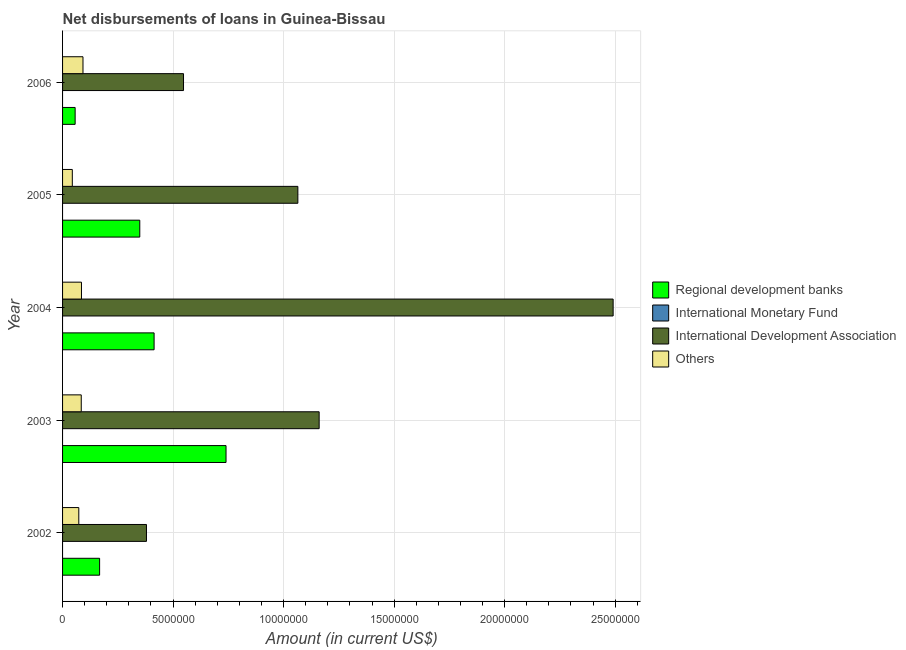How many different coloured bars are there?
Ensure brevity in your answer.  3. How many groups of bars are there?
Keep it short and to the point. 5. Are the number of bars per tick equal to the number of legend labels?
Your response must be concise. No. Are the number of bars on each tick of the Y-axis equal?
Your answer should be compact. Yes. How many bars are there on the 4th tick from the top?
Offer a very short reply. 3. How many bars are there on the 2nd tick from the bottom?
Provide a succinct answer. 3. What is the label of the 1st group of bars from the top?
Ensure brevity in your answer.  2006. What is the amount of loan disimbursed by other organisations in 2006?
Your answer should be compact. 9.24e+05. Across all years, what is the maximum amount of loan disimbursed by other organisations?
Your response must be concise. 9.24e+05. What is the total amount of loan disimbursed by international monetary fund in the graph?
Make the answer very short. 0. What is the difference between the amount of loan disimbursed by international development association in 2004 and that in 2006?
Your response must be concise. 1.94e+07. What is the difference between the amount of loan disimbursed by regional development banks in 2003 and the amount of loan disimbursed by international monetary fund in 2006?
Your response must be concise. 7.40e+06. What is the average amount of loan disimbursed by other organisations per year?
Your answer should be very brief. 7.60e+05. In the year 2004, what is the difference between the amount of loan disimbursed by international development association and amount of loan disimbursed by regional development banks?
Make the answer very short. 2.08e+07. In how many years, is the amount of loan disimbursed by regional development banks greater than 12000000 US$?
Offer a very short reply. 0. What is the ratio of the amount of loan disimbursed by regional development banks in 2003 to that in 2004?
Your response must be concise. 1.79. Is the amount of loan disimbursed by international development association in 2002 less than that in 2005?
Give a very brief answer. Yes. What is the difference between the highest and the second highest amount of loan disimbursed by regional development banks?
Offer a terse response. 3.25e+06. What is the difference between the highest and the lowest amount of loan disimbursed by other organisations?
Your response must be concise. 4.83e+05. Is the sum of the amount of loan disimbursed by regional development banks in 2002 and 2005 greater than the maximum amount of loan disimbursed by other organisations across all years?
Give a very brief answer. Yes. Is it the case that in every year, the sum of the amount of loan disimbursed by international monetary fund and amount of loan disimbursed by international development association is greater than the sum of amount of loan disimbursed by regional development banks and amount of loan disimbursed by other organisations?
Your answer should be very brief. Yes. Are all the bars in the graph horizontal?
Make the answer very short. Yes. How many years are there in the graph?
Your answer should be compact. 5. Does the graph contain grids?
Provide a succinct answer. Yes. How many legend labels are there?
Your response must be concise. 4. What is the title of the graph?
Give a very brief answer. Net disbursements of loans in Guinea-Bissau. What is the label or title of the X-axis?
Offer a terse response. Amount (in current US$). What is the Amount (in current US$) in Regional development banks in 2002?
Keep it short and to the point. 1.68e+06. What is the Amount (in current US$) of International Monetary Fund in 2002?
Offer a very short reply. 0. What is the Amount (in current US$) of International Development Association in 2002?
Give a very brief answer. 3.80e+06. What is the Amount (in current US$) in Others in 2002?
Your response must be concise. 7.34e+05. What is the Amount (in current US$) of Regional development banks in 2003?
Offer a very short reply. 7.40e+06. What is the Amount (in current US$) of International Monetary Fund in 2003?
Your response must be concise. 0. What is the Amount (in current US$) in International Development Association in 2003?
Your answer should be compact. 1.16e+07. What is the Amount (in current US$) of Others in 2003?
Ensure brevity in your answer.  8.45e+05. What is the Amount (in current US$) in Regional development banks in 2004?
Offer a very short reply. 4.14e+06. What is the Amount (in current US$) in International Development Association in 2004?
Keep it short and to the point. 2.49e+07. What is the Amount (in current US$) of Others in 2004?
Ensure brevity in your answer.  8.55e+05. What is the Amount (in current US$) of Regional development banks in 2005?
Your response must be concise. 3.49e+06. What is the Amount (in current US$) of International Monetary Fund in 2005?
Provide a short and direct response. 0. What is the Amount (in current US$) in International Development Association in 2005?
Ensure brevity in your answer.  1.06e+07. What is the Amount (in current US$) of Others in 2005?
Make the answer very short. 4.41e+05. What is the Amount (in current US$) of Regional development banks in 2006?
Keep it short and to the point. 5.69e+05. What is the Amount (in current US$) in International Monetary Fund in 2006?
Make the answer very short. 0. What is the Amount (in current US$) in International Development Association in 2006?
Your answer should be compact. 5.47e+06. What is the Amount (in current US$) in Others in 2006?
Give a very brief answer. 9.24e+05. Across all years, what is the maximum Amount (in current US$) of Regional development banks?
Offer a very short reply. 7.40e+06. Across all years, what is the maximum Amount (in current US$) of International Development Association?
Keep it short and to the point. 2.49e+07. Across all years, what is the maximum Amount (in current US$) in Others?
Your answer should be compact. 9.24e+05. Across all years, what is the minimum Amount (in current US$) in Regional development banks?
Provide a short and direct response. 5.69e+05. Across all years, what is the minimum Amount (in current US$) of International Development Association?
Provide a succinct answer. 3.80e+06. Across all years, what is the minimum Amount (in current US$) in Others?
Make the answer very short. 4.41e+05. What is the total Amount (in current US$) in Regional development banks in the graph?
Offer a very short reply. 1.73e+07. What is the total Amount (in current US$) in International Monetary Fund in the graph?
Your response must be concise. 0. What is the total Amount (in current US$) in International Development Association in the graph?
Provide a short and direct response. 5.64e+07. What is the total Amount (in current US$) of Others in the graph?
Provide a short and direct response. 3.80e+06. What is the difference between the Amount (in current US$) in Regional development banks in 2002 and that in 2003?
Make the answer very short. -5.72e+06. What is the difference between the Amount (in current US$) in International Development Association in 2002 and that in 2003?
Your answer should be very brief. -7.81e+06. What is the difference between the Amount (in current US$) of Others in 2002 and that in 2003?
Make the answer very short. -1.11e+05. What is the difference between the Amount (in current US$) in Regional development banks in 2002 and that in 2004?
Your answer should be compact. -2.46e+06. What is the difference between the Amount (in current US$) of International Development Association in 2002 and that in 2004?
Ensure brevity in your answer.  -2.11e+07. What is the difference between the Amount (in current US$) in Others in 2002 and that in 2004?
Your answer should be compact. -1.21e+05. What is the difference between the Amount (in current US$) of Regional development banks in 2002 and that in 2005?
Ensure brevity in your answer.  -1.82e+06. What is the difference between the Amount (in current US$) in International Development Association in 2002 and that in 2005?
Give a very brief answer. -6.85e+06. What is the difference between the Amount (in current US$) of Others in 2002 and that in 2005?
Keep it short and to the point. 2.93e+05. What is the difference between the Amount (in current US$) in Regional development banks in 2002 and that in 2006?
Keep it short and to the point. 1.11e+06. What is the difference between the Amount (in current US$) of International Development Association in 2002 and that in 2006?
Provide a succinct answer. -1.68e+06. What is the difference between the Amount (in current US$) of Others in 2002 and that in 2006?
Give a very brief answer. -1.90e+05. What is the difference between the Amount (in current US$) in Regional development banks in 2003 and that in 2004?
Keep it short and to the point. 3.25e+06. What is the difference between the Amount (in current US$) in International Development Association in 2003 and that in 2004?
Your answer should be compact. -1.33e+07. What is the difference between the Amount (in current US$) of Regional development banks in 2003 and that in 2005?
Make the answer very short. 3.90e+06. What is the difference between the Amount (in current US$) of International Development Association in 2003 and that in 2005?
Make the answer very short. 9.63e+05. What is the difference between the Amount (in current US$) in Others in 2003 and that in 2005?
Ensure brevity in your answer.  4.04e+05. What is the difference between the Amount (in current US$) of Regional development banks in 2003 and that in 2006?
Ensure brevity in your answer.  6.83e+06. What is the difference between the Amount (in current US$) of International Development Association in 2003 and that in 2006?
Give a very brief answer. 6.14e+06. What is the difference between the Amount (in current US$) in Others in 2003 and that in 2006?
Give a very brief answer. -7.90e+04. What is the difference between the Amount (in current US$) of Regional development banks in 2004 and that in 2005?
Offer a very short reply. 6.48e+05. What is the difference between the Amount (in current US$) in International Development Association in 2004 and that in 2005?
Make the answer very short. 1.43e+07. What is the difference between the Amount (in current US$) in Others in 2004 and that in 2005?
Keep it short and to the point. 4.14e+05. What is the difference between the Amount (in current US$) in Regional development banks in 2004 and that in 2006?
Offer a very short reply. 3.57e+06. What is the difference between the Amount (in current US$) in International Development Association in 2004 and that in 2006?
Make the answer very short. 1.94e+07. What is the difference between the Amount (in current US$) of Others in 2004 and that in 2006?
Keep it short and to the point. -6.90e+04. What is the difference between the Amount (in current US$) of Regional development banks in 2005 and that in 2006?
Your answer should be very brief. 2.92e+06. What is the difference between the Amount (in current US$) of International Development Association in 2005 and that in 2006?
Your response must be concise. 5.17e+06. What is the difference between the Amount (in current US$) of Others in 2005 and that in 2006?
Your answer should be very brief. -4.83e+05. What is the difference between the Amount (in current US$) of Regional development banks in 2002 and the Amount (in current US$) of International Development Association in 2003?
Offer a terse response. -9.93e+06. What is the difference between the Amount (in current US$) of Regional development banks in 2002 and the Amount (in current US$) of Others in 2003?
Your answer should be very brief. 8.31e+05. What is the difference between the Amount (in current US$) of International Development Association in 2002 and the Amount (in current US$) of Others in 2003?
Ensure brevity in your answer.  2.95e+06. What is the difference between the Amount (in current US$) of Regional development banks in 2002 and the Amount (in current US$) of International Development Association in 2004?
Make the answer very short. -2.32e+07. What is the difference between the Amount (in current US$) in Regional development banks in 2002 and the Amount (in current US$) in Others in 2004?
Offer a very short reply. 8.21e+05. What is the difference between the Amount (in current US$) of International Development Association in 2002 and the Amount (in current US$) of Others in 2004?
Give a very brief answer. 2.94e+06. What is the difference between the Amount (in current US$) in Regional development banks in 2002 and the Amount (in current US$) in International Development Association in 2005?
Ensure brevity in your answer.  -8.97e+06. What is the difference between the Amount (in current US$) of Regional development banks in 2002 and the Amount (in current US$) of Others in 2005?
Offer a very short reply. 1.24e+06. What is the difference between the Amount (in current US$) in International Development Association in 2002 and the Amount (in current US$) in Others in 2005?
Your response must be concise. 3.36e+06. What is the difference between the Amount (in current US$) in Regional development banks in 2002 and the Amount (in current US$) in International Development Association in 2006?
Provide a short and direct response. -3.80e+06. What is the difference between the Amount (in current US$) of Regional development banks in 2002 and the Amount (in current US$) of Others in 2006?
Give a very brief answer. 7.52e+05. What is the difference between the Amount (in current US$) of International Development Association in 2002 and the Amount (in current US$) of Others in 2006?
Provide a succinct answer. 2.87e+06. What is the difference between the Amount (in current US$) of Regional development banks in 2003 and the Amount (in current US$) of International Development Association in 2004?
Offer a very short reply. -1.75e+07. What is the difference between the Amount (in current US$) of Regional development banks in 2003 and the Amount (in current US$) of Others in 2004?
Provide a succinct answer. 6.54e+06. What is the difference between the Amount (in current US$) in International Development Association in 2003 and the Amount (in current US$) in Others in 2004?
Make the answer very short. 1.08e+07. What is the difference between the Amount (in current US$) in Regional development banks in 2003 and the Amount (in current US$) in International Development Association in 2005?
Give a very brief answer. -3.25e+06. What is the difference between the Amount (in current US$) of Regional development banks in 2003 and the Amount (in current US$) of Others in 2005?
Provide a short and direct response. 6.95e+06. What is the difference between the Amount (in current US$) of International Development Association in 2003 and the Amount (in current US$) of Others in 2005?
Make the answer very short. 1.12e+07. What is the difference between the Amount (in current US$) in Regional development banks in 2003 and the Amount (in current US$) in International Development Association in 2006?
Your response must be concise. 1.92e+06. What is the difference between the Amount (in current US$) of Regional development banks in 2003 and the Amount (in current US$) of Others in 2006?
Your response must be concise. 6.47e+06. What is the difference between the Amount (in current US$) of International Development Association in 2003 and the Amount (in current US$) of Others in 2006?
Provide a succinct answer. 1.07e+07. What is the difference between the Amount (in current US$) in Regional development banks in 2004 and the Amount (in current US$) in International Development Association in 2005?
Provide a short and direct response. -6.50e+06. What is the difference between the Amount (in current US$) of Regional development banks in 2004 and the Amount (in current US$) of Others in 2005?
Your answer should be very brief. 3.70e+06. What is the difference between the Amount (in current US$) in International Development Association in 2004 and the Amount (in current US$) in Others in 2005?
Your answer should be compact. 2.45e+07. What is the difference between the Amount (in current US$) in Regional development banks in 2004 and the Amount (in current US$) in International Development Association in 2006?
Make the answer very short. -1.33e+06. What is the difference between the Amount (in current US$) of Regional development banks in 2004 and the Amount (in current US$) of Others in 2006?
Offer a very short reply. 3.22e+06. What is the difference between the Amount (in current US$) of International Development Association in 2004 and the Amount (in current US$) of Others in 2006?
Your answer should be very brief. 2.40e+07. What is the difference between the Amount (in current US$) of Regional development banks in 2005 and the Amount (in current US$) of International Development Association in 2006?
Provide a succinct answer. -1.98e+06. What is the difference between the Amount (in current US$) of Regional development banks in 2005 and the Amount (in current US$) of Others in 2006?
Give a very brief answer. 2.57e+06. What is the difference between the Amount (in current US$) in International Development Association in 2005 and the Amount (in current US$) in Others in 2006?
Your answer should be compact. 9.72e+06. What is the average Amount (in current US$) in Regional development banks per year?
Keep it short and to the point. 3.45e+06. What is the average Amount (in current US$) in International Monetary Fund per year?
Make the answer very short. 0. What is the average Amount (in current US$) of International Development Association per year?
Provide a succinct answer. 1.13e+07. What is the average Amount (in current US$) of Others per year?
Ensure brevity in your answer.  7.60e+05. In the year 2002, what is the difference between the Amount (in current US$) in Regional development banks and Amount (in current US$) in International Development Association?
Give a very brief answer. -2.12e+06. In the year 2002, what is the difference between the Amount (in current US$) in Regional development banks and Amount (in current US$) in Others?
Offer a terse response. 9.42e+05. In the year 2002, what is the difference between the Amount (in current US$) of International Development Association and Amount (in current US$) of Others?
Give a very brief answer. 3.06e+06. In the year 2003, what is the difference between the Amount (in current US$) of Regional development banks and Amount (in current US$) of International Development Association?
Keep it short and to the point. -4.21e+06. In the year 2003, what is the difference between the Amount (in current US$) of Regional development banks and Amount (in current US$) of Others?
Your response must be concise. 6.55e+06. In the year 2003, what is the difference between the Amount (in current US$) in International Development Association and Amount (in current US$) in Others?
Your answer should be compact. 1.08e+07. In the year 2004, what is the difference between the Amount (in current US$) of Regional development banks and Amount (in current US$) of International Development Association?
Make the answer very short. -2.08e+07. In the year 2004, what is the difference between the Amount (in current US$) in Regional development banks and Amount (in current US$) in Others?
Provide a succinct answer. 3.29e+06. In the year 2004, what is the difference between the Amount (in current US$) in International Development Association and Amount (in current US$) in Others?
Offer a terse response. 2.41e+07. In the year 2005, what is the difference between the Amount (in current US$) in Regional development banks and Amount (in current US$) in International Development Association?
Your answer should be very brief. -7.15e+06. In the year 2005, what is the difference between the Amount (in current US$) in Regional development banks and Amount (in current US$) in Others?
Make the answer very short. 3.05e+06. In the year 2005, what is the difference between the Amount (in current US$) of International Development Association and Amount (in current US$) of Others?
Ensure brevity in your answer.  1.02e+07. In the year 2006, what is the difference between the Amount (in current US$) in Regional development banks and Amount (in current US$) in International Development Association?
Provide a short and direct response. -4.90e+06. In the year 2006, what is the difference between the Amount (in current US$) in Regional development banks and Amount (in current US$) in Others?
Give a very brief answer. -3.55e+05. In the year 2006, what is the difference between the Amount (in current US$) in International Development Association and Amount (in current US$) in Others?
Provide a short and direct response. 4.55e+06. What is the ratio of the Amount (in current US$) of Regional development banks in 2002 to that in 2003?
Your response must be concise. 0.23. What is the ratio of the Amount (in current US$) of International Development Association in 2002 to that in 2003?
Give a very brief answer. 0.33. What is the ratio of the Amount (in current US$) of Others in 2002 to that in 2003?
Offer a terse response. 0.87. What is the ratio of the Amount (in current US$) of Regional development banks in 2002 to that in 2004?
Your answer should be compact. 0.4. What is the ratio of the Amount (in current US$) in International Development Association in 2002 to that in 2004?
Your response must be concise. 0.15. What is the ratio of the Amount (in current US$) in Others in 2002 to that in 2004?
Give a very brief answer. 0.86. What is the ratio of the Amount (in current US$) of Regional development banks in 2002 to that in 2005?
Provide a succinct answer. 0.48. What is the ratio of the Amount (in current US$) of International Development Association in 2002 to that in 2005?
Your response must be concise. 0.36. What is the ratio of the Amount (in current US$) in Others in 2002 to that in 2005?
Your answer should be very brief. 1.66. What is the ratio of the Amount (in current US$) in Regional development banks in 2002 to that in 2006?
Ensure brevity in your answer.  2.95. What is the ratio of the Amount (in current US$) in International Development Association in 2002 to that in 2006?
Ensure brevity in your answer.  0.69. What is the ratio of the Amount (in current US$) of Others in 2002 to that in 2006?
Offer a very short reply. 0.79. What is the ratio of the Amount (in current US$) of Regional development banks in 2003 to that in 2004?
Offer a terse response. 1.79. What is the ratio of the Amount (in current US$) in International Development Association in 2003 to that in 2004?
Your response must be concise. 0.47. What is the ratio of the Amount (in current US$) in Others in 2003 to that in 2004?
Your response must be concise. 0.99. What is the ratio of the Amount (in current US$) in Regional development banks in 2003 to that in 2005?
Make the answer very short. 2.12. What is the ratio of the Amount (in current US$) in International Development Association in 2003 to that in 2005?
Make the answer very short. 1.09. What is the ratio of the Amount (in current US$) of Others in 2003 to that in 2005?
Make the answer very short. 1.92. What is the ratio of the Amount (in current US$) of Regional development banks in 2003 to that in 2006?
Your response must be concise. 13. What is the ratio of the Amount (in current US$) in International Development Association in 2003 to that in 2006?
Provide a short and direct response. 2.12. What is the ratio of the Amount (in current US$) in Others in 2003 to that in 2006?
Give a very brief answer. 0.91. What is the ratio of the Amount (in current US$) in Regional development banks in 2004 to that in 2005?
Offer a very short reply. 1.19. What is the ratio of the Amount (in current US$) of International Development Association in 2004 to that in 2005?
Offer a terse response. 2.34. What is the ratio of the Amount (in current US$) of Others in 2004 to that in 2005?
Offer a terse response. 1.94. What is the ratio of the Amount (in current US$) in Regional development banks in 2004 to that in 2006?
Your response must be concise. 7.28. What is the ratio of the Amount (in current US$) of International Development Association in 2004 to that in 2006?
Ensure brevity in your answer.  4.55. What is the ratio of the Amount (in current US$) of Others in 2004 to that in 2006?
Your answer should be very brief. 0.93. What is the ratio of the Amount (in current US$) of Regional development banks in 2005 to that in 2006?
Provide a short and direct response. 6.14. What is the ratio of the Amount (in current US$) in International Development Association in 2005 to that in 2006?
Your answer should be very brief. 1.95. What is the ratio of the Amount (in current US$) of Others in 2005 to that in 2006?
Your answer should be compact. 0.48. What is the difference between the highest and the second highest Amount (in current US$) of Regional development banks?
Give a very brief answer. 3.25e+06. What is the difference between the highest and the second highest Amount (in current US$) in International Development Association?
Your response must be concise. 1.33e+07. What is the difference between the highest and the second highest Amount (in current US$) of Others?
Offer a terse response. 6.90e+04. What is the difference between the highest and the lowest Amount (in current US$) in Regional development banks?
Offer a terse response. 6.83e+06. What is the difference between the highest and the lowest Amount (in current US$) of International Development Association?
Provide a short and direct response. 2.11e+07. What is the difference between the highest and the lowest Amount (in current US$) of Others?
Your answer should be very brief. 4.83e+05. 